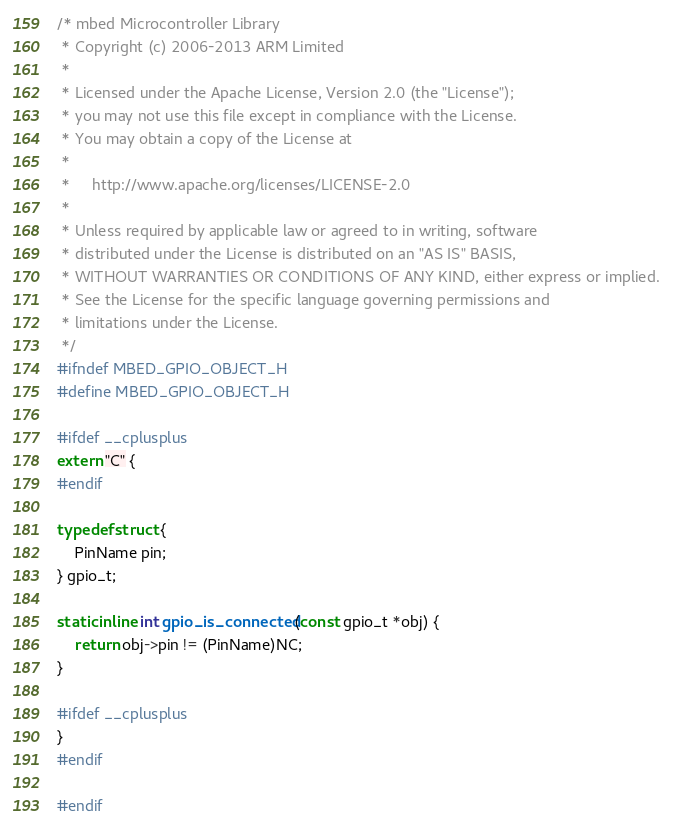<code> <loc_0><loc_0><loc_500><loc_500><_C_>/* mbed Microcontroller Library
 * Copyright (c) 2006-2013 ARM Limited
 *
 * Licensed under the Apache License, Version 2.0 (the "License");
 * you may not use this file except in compliance with the License.
 * You may obtain a copy of the License at
 *
 *     http://www.apache.org/licenses/LICENSE-2.0
 *
 * Unless required by applicable law or agreed to in writing, software
 * distributed under the License is distributed on an "AS IS" BASIS,
 * WITHOUT WARRANTIES OR CONDITIONS OF ANY KIND, either express or implied.
 * See the License for the specific language governing permissions and
 * limitations under the License.
 */
#ifndef MBED_GPIO_OBJECT_H
#define MBED_GPIO_OBJECT_H

#ifdef __cplusplus
extern "C" {
#endif

typedef struct {
    PinName pin;
} gpio_t;

static inline int gpio_is_connected(const gpio_t *obj) {
    return obj->pin != (PinName)NC;
}

#ifdef __cplusplus
}
#endif

#endif
</code> 